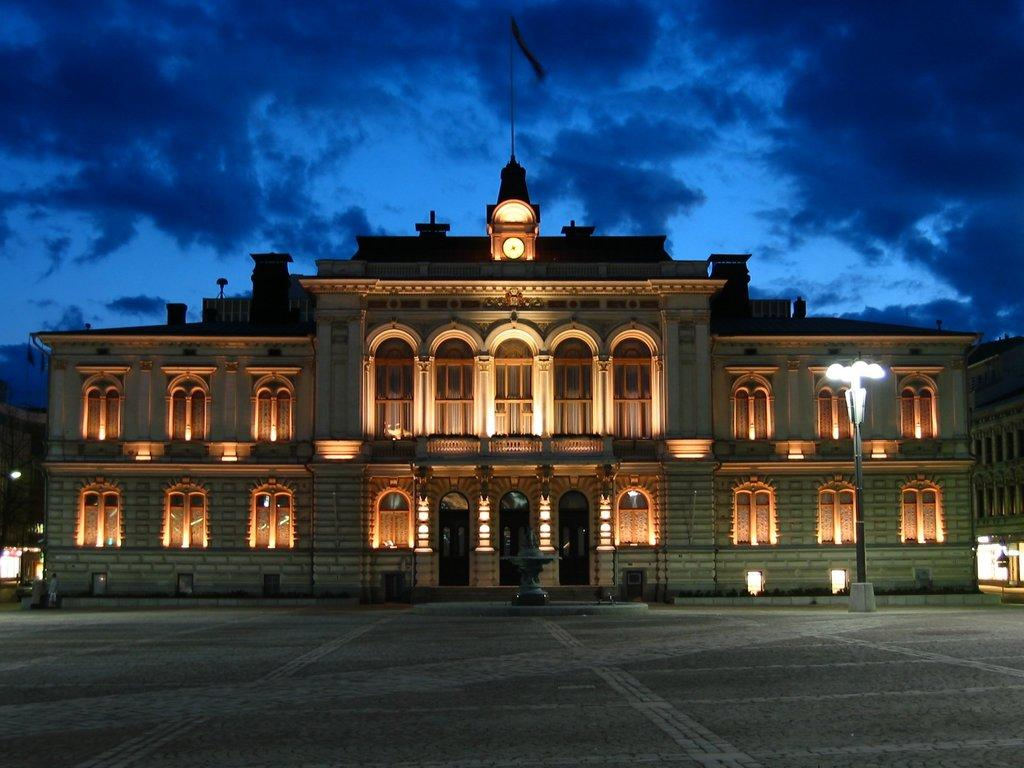What type of building is in the image? There is a big palace in the image. What object can be seen on the palace? There is a clock in the image. What area is designated for vehicles in the image? There is a parking area in the image. How many sheep are running in the parking area in the image? There are no sheep present in the image, and they are not running in the parking area. 